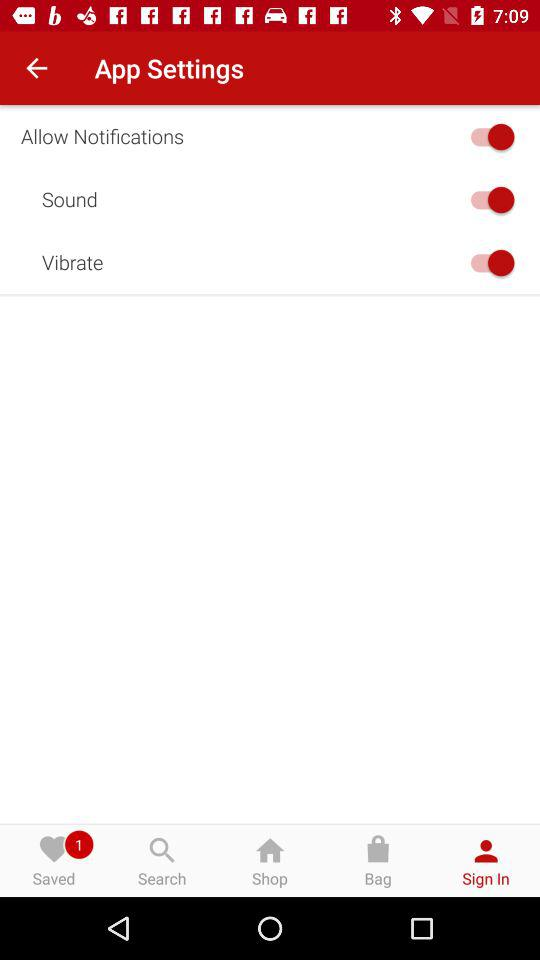What is the current status of the "Allow Notifications"? The status is "on". 